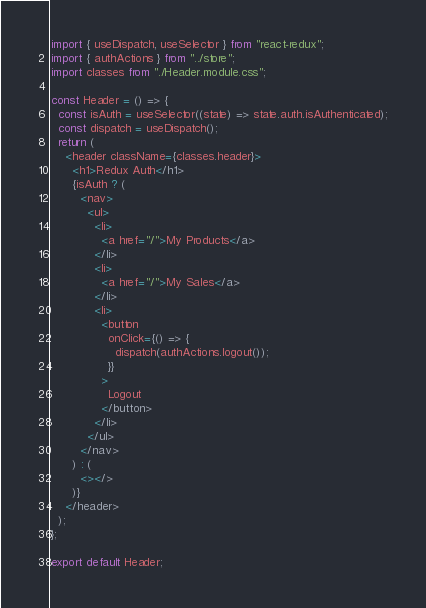Convert code to text. <code><loc_0><loc_0><loc_500><loc_500><_JavaScript_>import { useDispatch, useSelector } from "react-redux";
import { authActions } from "../store";
import classes from "./Header.module.css";

const Header = () => {
  const isAuth = useSelector((state) => state.auth.isAuthenticated);
  const dispatch = useDispatch();
  return (
    <header className={classes.header}>
      <h1>Redux Auth</h1>
      {isAuth ? (
        <nav>
          <ul>
            <li>
              <a href="/">My Products</a>
            </li>
            <li>
              <a href="/">My Sales</a>
            </li>
            <li>
              <button
                onClick={() => {
                  dispatch(authActions.logout());
                }}
              >
                Logout
              </button>
            </li>
          </ul>
        </nav>
      ) : (
        <></>
      )}
    </header>
  );
};

export default Header;
</code> 